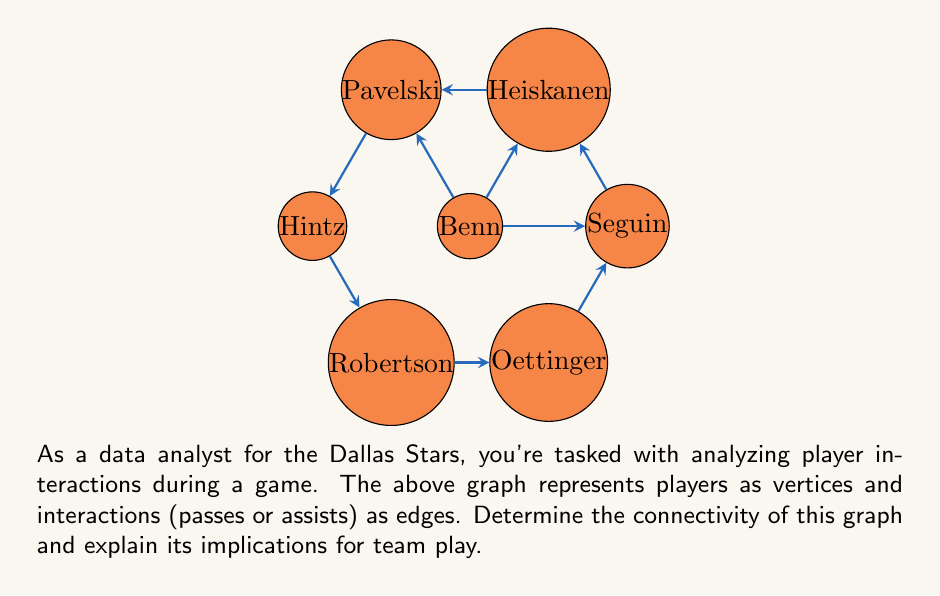Teach me how to tackle this problem. To determine the connectivity of this graph, we need to analyze its structure and find the minimum number of vertices that need to be removed to disconnect the graph. Let's approach this step-by-step:

1) First, we observe that the graph is connected, as there is a path between any two vertices.

2) We need to find the minimum number of vertices whose removal would disconnect the graph. This number is called the vertex connectivity of the graph.

3) Let's examine potential cut-vertices:
   - Removing Benn (center) doesn't disconnect the graph.
   - Removing Seguin or Heiskanen doesn't disconnect the graph.
   - Removing Pavelski doesn't disconnect the graph.
   - Removing Hintz, Robertson, or Oettinger doesn't disconnect the graph.

4) We find that there is no single vertex whose removal would disconnect the graph.

5) Now, let's consider pairs of vertices:
   - Removing Pavelski and Hintz disconnects the graph into two components: {Benn, Seguin, Heiskanen} and {Robertson, Oettinger}.

6) We can't find any single vertex that disconnects the graph, but we found a pair of vertices that does. Therefore, the vertex connectivity of this graph is 2.

7) In graph theory terms, this means the graph is 2-connected or biconnected.

Implications for team play:
- The biconnectivity suggests good overall team connectivity.
- There's no single player whose absence would completely disrupt team communication.
- However, the removal of two specific players (Pavelski and Hintz in this case) could potentially split the team into two disconnected groups.
- This analysis could help in developing strategies to maintain team cohesion and identifying key player partnerships.
Answer: The graph is 2-connected (biconnected). 